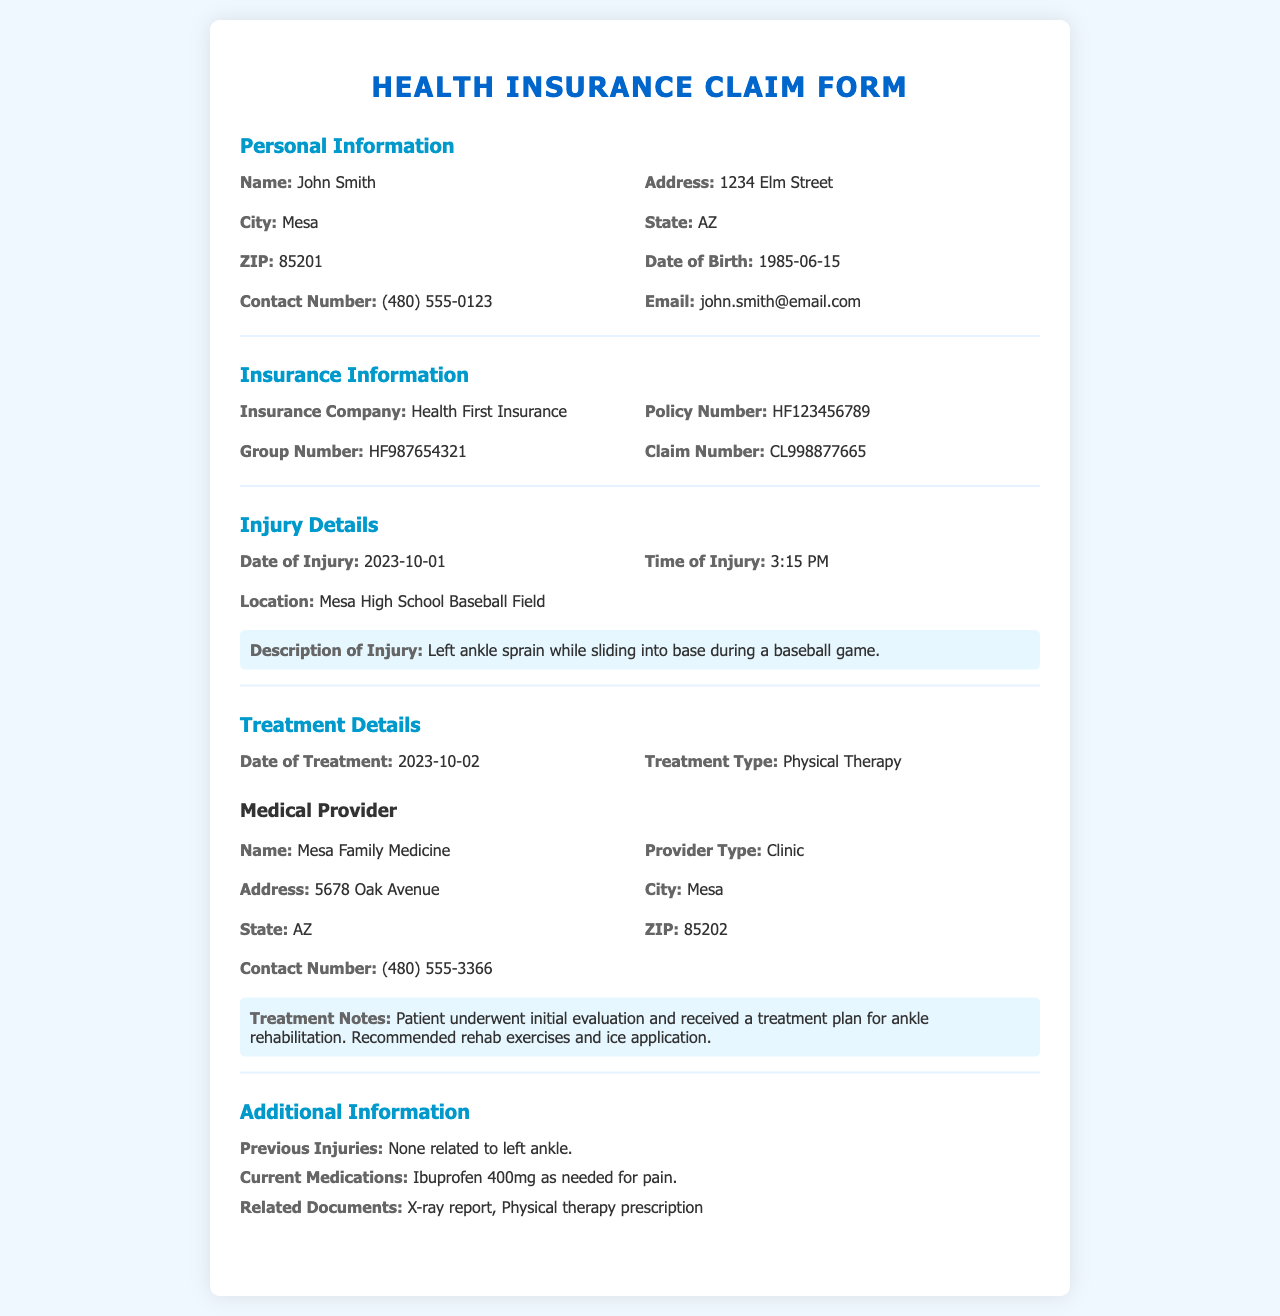What is the name of the patient? The name of the patient is provided in the personal information section of the document.
Answer: John Smith What is the date of injury? The date of injury is mentioned under injury details in the document.
Answer: 2023-10-01 What treatment type was received? The treatment type is listed in the treatment details section of the document.
Answer: Physical Therapy What is the contact number of the medical provider? The contact number can be found in the medical provider information within the document.
Answer: (480) 555-3366 What is the insurance company's name? The insurance company name is specified in the insurance information section of the document.
Answer: Health First Insurance What was the location of the injury? The injury location is detailed in the injury details section of the document.
Answer: Mesa High School Baseball Field How many previous injuries are listed? Previous injuries are addressed in the additional information section, indicating how many injuries occurred before.
Answer: None related to left ankle What medication is currently being taken? The current medication is found in the additional information part of the document.
Answer: Ibuprofen 400mg as needed for pain What was the time of injury? The time of injury is indicated in the injury details section of the document.
Answer: 3:15 PM 